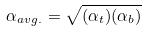<formula> <loc_0><loc_0><loc_500><loc_500>\alpha _ { a v g . } = \sqrt { ( \alpha _ { t } ) ( \alpha _ { b } ) }</formula> 